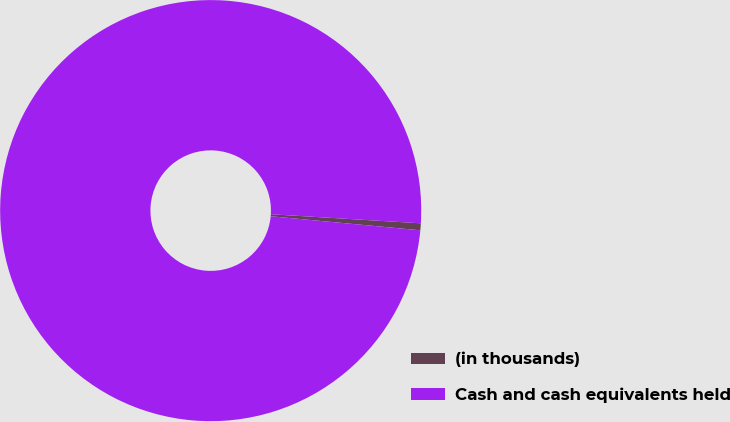Convert chart to OTSL. <chart><loc_0><loc_0><loc_500><loc_500><pie_chart><fcel>(in thousands)<fcel>Cash and cash equivalents held<nl><fcel>0.53%<fcel>99.47%<nl></chart> 